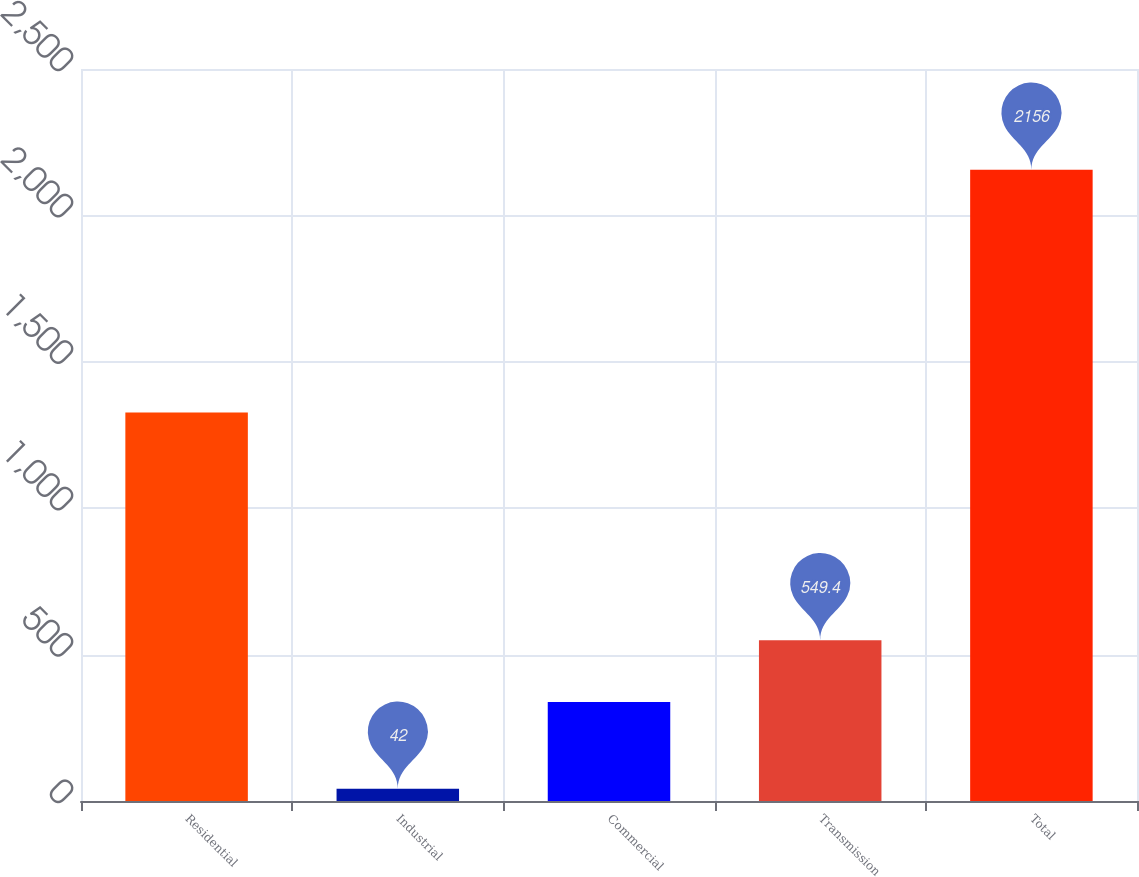Convert chart. <chart><loc_0><loc_0><loc_500><loc_500><bar_chart><fcel>Residential<fcel>Industrial<fcel>Commercial<fcel>Transmission<fcel>Total<nl><fcel>1327<fcel>42<fcel>338<fcel>549.4<fcel>2156<nl></chart> 